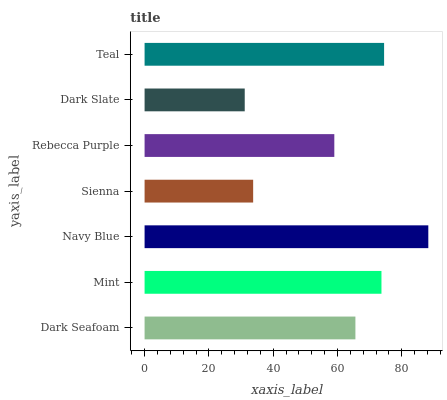Is Dark Slate the minimum?
Answer yes or no. Yes. Is Navy Blue the maximum?
Answer yes or no. Yes. Is Mint the minimum?
Answer yes or no. No. Is Mint the maximum?
Answer yes or no. No. Is Mint greater than Dark Seafoam?
Answer yes or no. Yes. Is Dark Seafoam less than Mint?
Answer yes or no. Yes. Is Dark Seafoam greater than Mint?
Answer yes or no. No. Is Mint less than Dark Seafoam?
Answer yes or no. No. Is Dark Seafoam the high median?
Answer yes or no. Yes. Is Dark Seafoam the low median?
Answer yes or no. Yes. Is Navy Blue the high median?
Answer yes or no. No. Is Mint the low median?
Answer yes or no. No. 